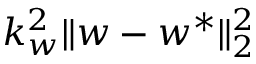<formula> <loc_0><loc_0><loc_500><loc_500>k _ { w } ^ { 2 } \| w - w ^ { * } \| _ { 2 } ^ { 2 }</formula> 